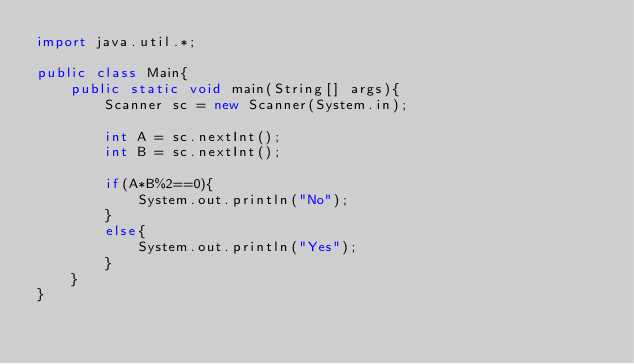<code> <loc_0><loc_0><loc_500><loc_500><_Java_>import java.util.*;

public class Main{
    public static void main(String[] args){
        Scanner sc = new Scanner(System.in);

        int A = sc.nextInt();
        int B = sc.nextInt();

        if(A*B%2==0){
            System.out.println("No");
        }
        else{
            System.out.println("Yes");
        }
    }
}</code> 